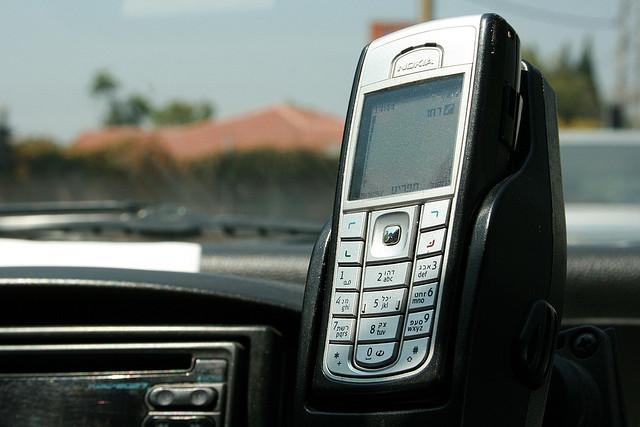Is anyone calling?
Give a very brief answer. No. Where is this phone?
Concise answer only. In car. What brand is this phone?
Write a very short answer. Nokia. Is it standing on a table?
Concise answer only. No. What is this item?
Quick response, please. Cell phone. 